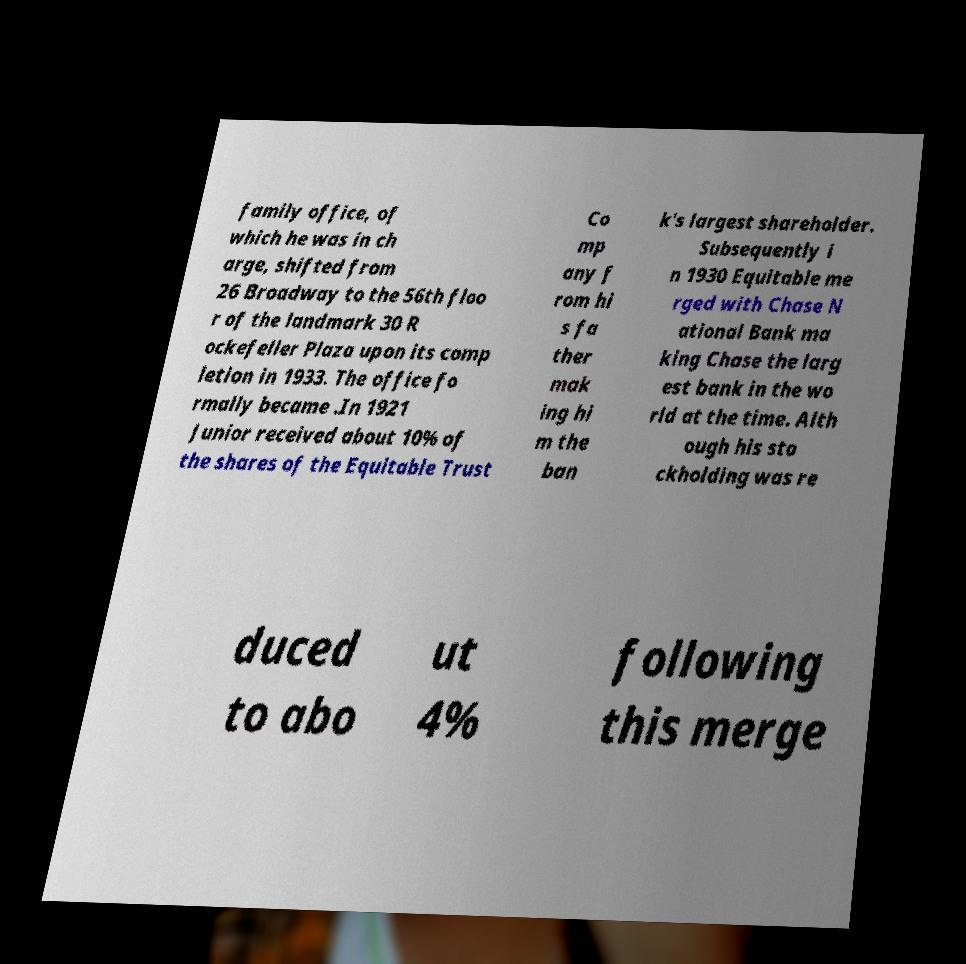Can you accurately transcribe the text from the provided image for me? family office, of which he was in ch arge, shifted from 26 Broadway to the 56th floo r of the landmark 30 R ockefeller Plaza upon its comp letion in 1933. The office fo rmally became .In 1921 Junior received about 10% of the shares of the Equitable Trust Co mp any f rom hi s fa ther mak ing hi m the ban k's largest shareholder. Subsequently i n 1930 Equitable me rged with Chase N ational Bank ma king Chase the larg est bank in the wo rld at the time. Alth ough his sto ckholding was re duced to abo ut 4% following this merge 